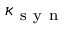Convert formula to latex. <formula><loc_0><loc_0><loc_500><loc_500>\kappa _ { s y n }</formula> 